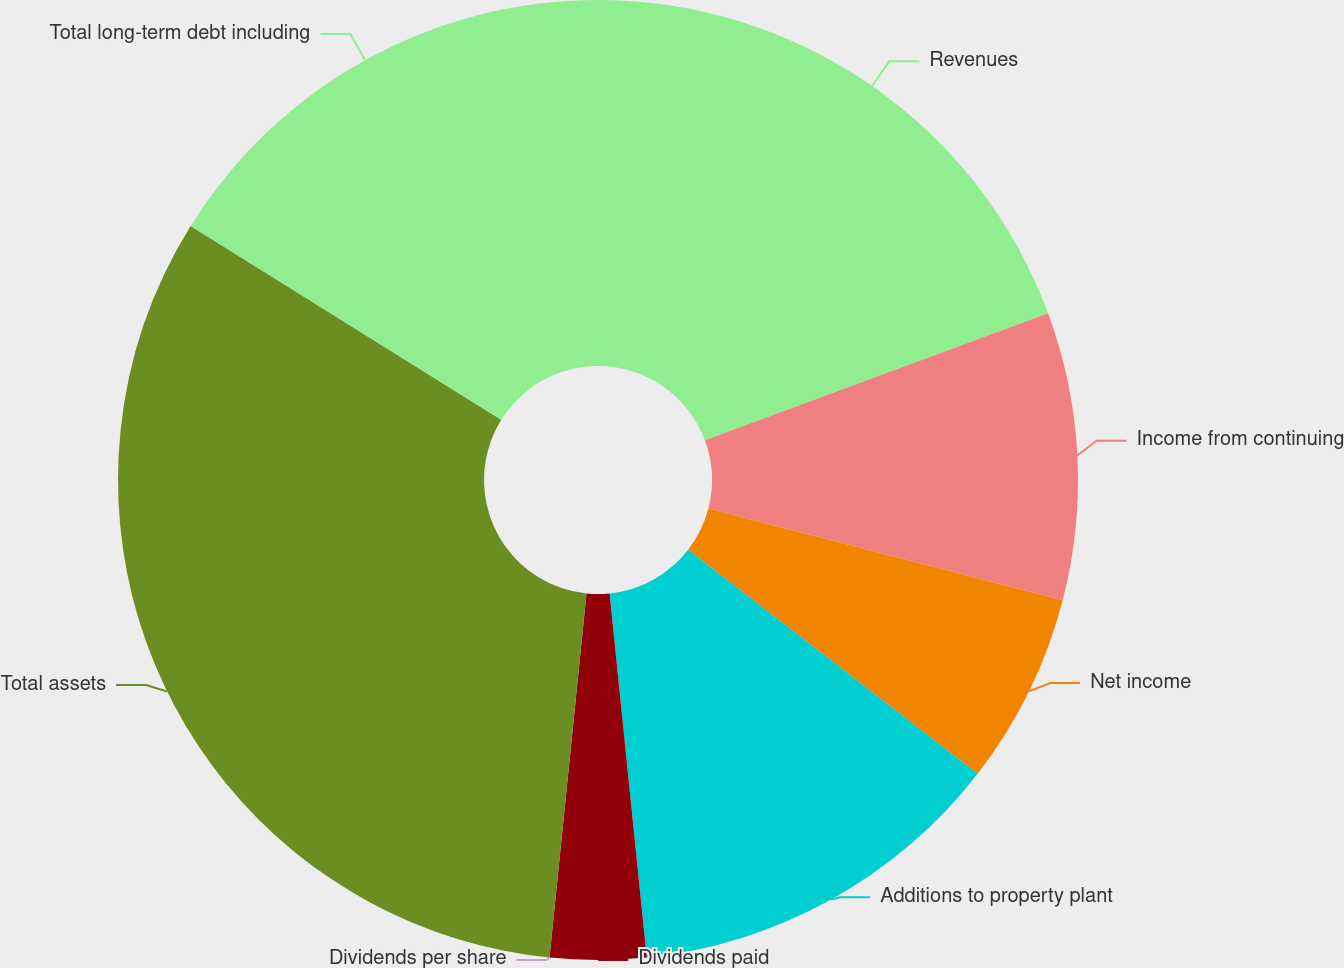<chart> <loc_0><loc_0><loc_500><loc_500><pie_chart><fcel>Revenues<fcel>Income from continuing<fcel>Net income<fcel>Additions to property plant<fcel>Dividends paid<fcel>Dividends per share<fcel>Total assets<fcel>Total long-term debt including<nl><fcel>19.35%<fcel>9.68%<fcel>6.45%<fcel>12.9%<fcel>3.23%<fcel>0.0%<fcel>32.26%<fcel>16.13%<nl></chart> 